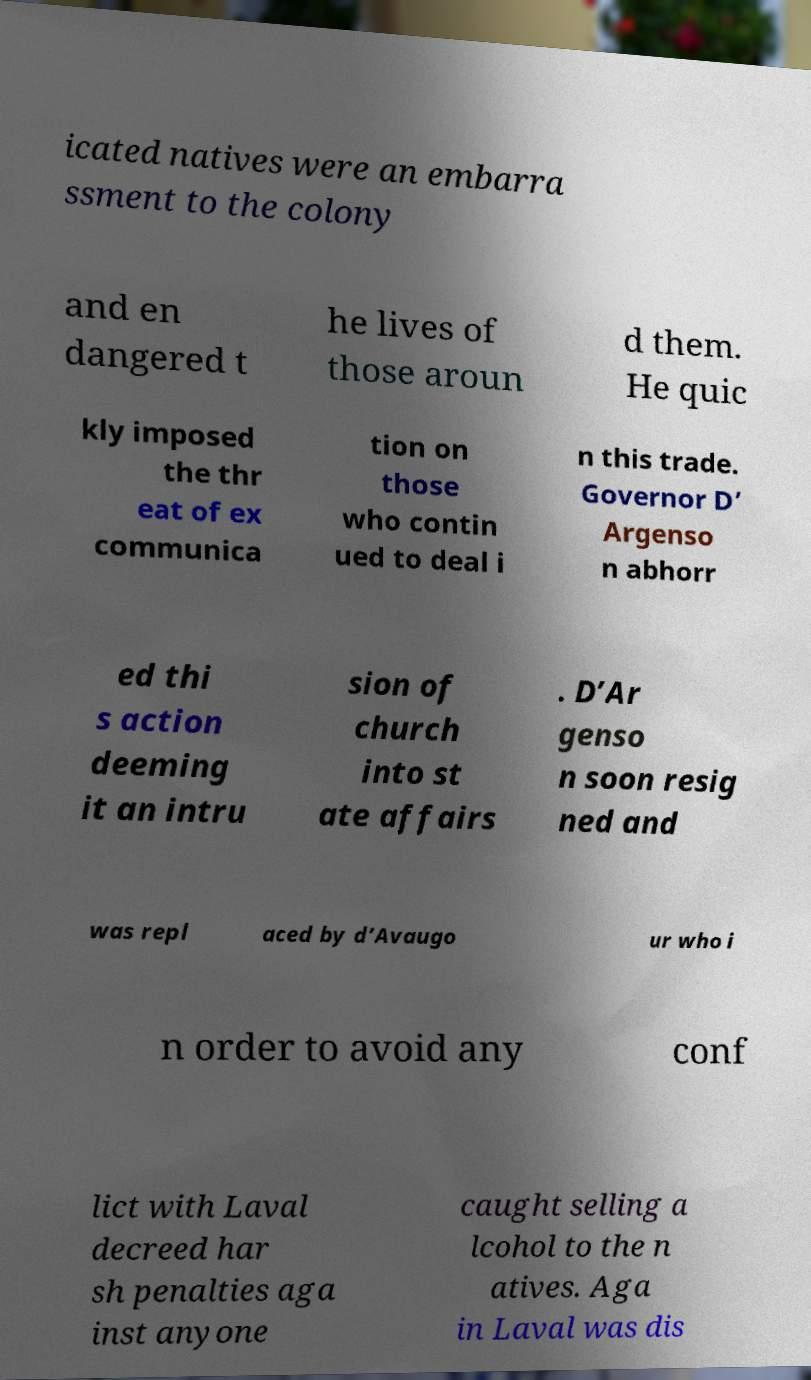Can you accurately transcribe the text from the provided image for me? icated natives were an embarra ssment to the colony and en dangered t he lives of those aroun d them. He quic kly imposed the thr eat of ex communica tion on those who contin ued to deal i n this trade. Governor D’ Argenso n abhorr ed thi s action deeming it an intru sion of church into st ate affairs . D’Ar genso n soon resig ned and was repl aced by d’Avaugo ur who i n order to avoid any conf lict with Laval decreed har sh penalties aga inst anyone caught selling a lcohol to the n atives. Aga in Laval was dis 